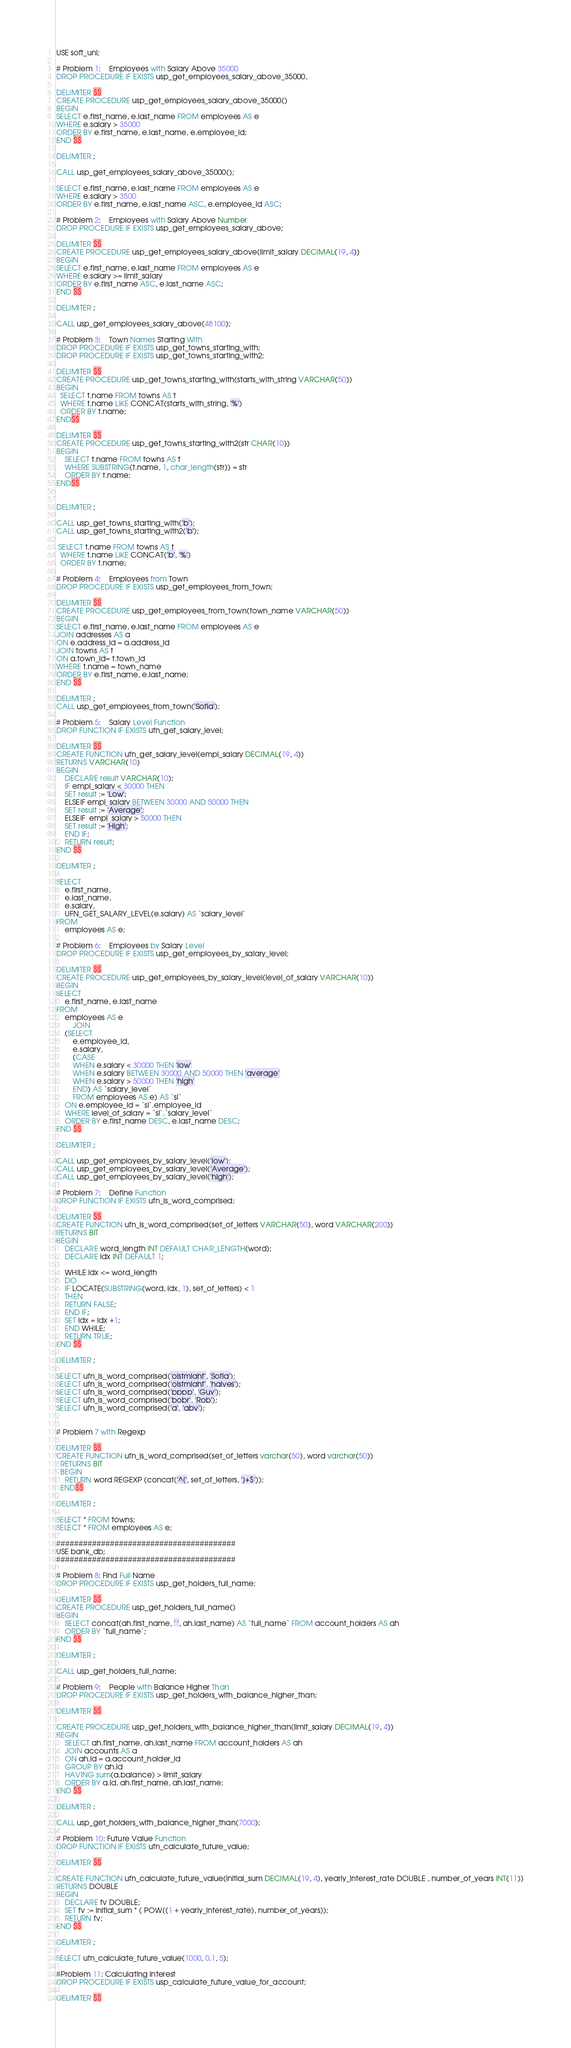Convert code to text. <code><loc_0><loc_0><loc_500><loc_500><_SQL_>USE soft_uni;

# Problem 1:	Employees with Salary Above 35000
DROP PROCEDURE IF EXISTS usp_get_employees_salary_above_35000,

DELIMITER $$
CREATE PROCEDURE usp_get_employees_salary_above_35000() 
BEGIN
SELECT e.first_name, e.last_name FROM employees AS e
WHERE e.salary > 35000
ORDER BY e.first_name, e.last_name, e.employee_id; 
END $$

DELIMITER ;

CALL usp_get_employees_salary_above_35000();

SELECT e.first_name, e.last_name FROM employees AS e
WHERE e.salary > 3500
ORDER BY e.first_name, e.last_name ASC, e.employee_id ASC; 

# Problem 2:	Employees with Salary Above Number
DROP PROCEDURE IF EXISTS usp_get_employees_salary_above;

DELIMITER $$
CREATE PROCEDURE usp_get_employees_salary_above(limit_salary DECIMAL(19, 4))
BEGIN
SELECT e.first_name, e.last_name FROM employees AS e
WHERE e.salary >= limit_salary
ORDER BY e.first_name ASC, e.last_name ASC;
END $$

DELIMITER ;

CALL usp_get_employees_salary_above(48100);

# Problem 3:	Town Names Starting With
DROP PROCEDURE IF EXISTS usp_get_towns_starting_with;
DROP PROCEDURE IF EXISTS usp_get_towns_starting_with2;

DELIMITER $$
CREATE PROCEDURE usp_get_towns_starting_with(starts_with_string VARCHAR(50))
BEGIN
  SELECT t.name FROM towns AS t
  WHERE t.name LIKE CONCAT(starts_with_string, '%')
  ORDER BY t.name;
END$$

DELIMITER $$
CREATE PROCEDURE usp_get_towns_starting_with2(str CHAR(10))
BEGIN
	SELECT t.name FROM towns AS t
	WHERE SUBSTRING(t.name, 1, char_length(str)) = str
    ORDER BY t.name;
END$$


DELIMITER ;

CALL usp_get_towns_starting_with('b');
CALL usp_get_towns_starting_with2('b');

 SELECT t.name FROM towns AS t
  WHERE t.name LIKE CONCAT('b', '%')
  ORDER BY t.name;

# Problem 4:	Employees from Town
DROP PROCEDURE IF EXISTS usp_get_employees_from_town;

DELIMITER $$
CREATE PROCEDURE usp_get_employees_from_town(town_name VARCHAR(50))
BEGIN
SELECT e.first_name, e.last_name FROM employees AS e
JOIN addresses AS a
ON e.address_id = a.address_id
JOIN towns AS t
ON a.town_id= t.town_id
WHERE t.name = town_name
ORDER BY e.first_name, e.last_name;
END $$

DELIMITER ;
CALL usp_get_employees_from_town('Sofia');

# Problem 5:	Salary Level Function
DROP FUNCTION IF EXISTS ufn_get_salary_level;

DELIMITER $$
CREATE FUNCTION ufn_get_salary_level(empl_salary DECIMAL(19, 4))
RETURNS VARCHAR(10) 
BEGIN
	DECLARE result VARCHAR(10);
    IF empl_salary < 30000 THEN
    SET result := 'Low';
    ELSEIF empl_salary BETWEEN 30000 AND 50000 THEN
    SET result := 'Average';
    ELSEIF  empl_salary > 50000 THEN
    SET result := 'High';
    END IF;
	RETURN result;
END $$

DELIMITER ;

SELECT 
    e.first_name,
    e.last_name,
    e.salary,
    UFN_GET_SALARY_LEVEL(e.salary) AS `salary_level`
FROM
    employees AS e;

# Problem 6:	Employees by Salary Level
DROP PROCEDURE IF EXISTS usp_get_employees_by_salary_level;

DELIMITER $$
CREATE PROCEDURE usp_get_employees_by_salary_level(level_of_salary VARCHAR(10))
BEGIN
SELECT 
    e.first_name, e.last_name
FROM
    employees AS e
        JOIN
    (SELECT 
        e.employee_id, 
        e.salary,
        (CASE 
        WHEN e.salary < 30000 THEN 'low'
        WHEN e.salary BETWEEN 30000 AND 50000 THEN 'average'
        WHEN e.salary > 50000 THEN 'high'
        END) AS `salary_level`
		FROM employees AS e) AS `sl`
	ON e.employee_id = `sl`.employee_id
    WHERE level_of_salary = `sl`.`salary_level`
    ORDER BY e.first_name DESC, e.last_name DESC;
END $$

DELIMITER ;

CALL usp_get_employees_by_salary_level('low');
CALL usp_get_employees_by_salary_level('Average');
CALL usp_get_employees_by_salary_level('high');

# Problem 7:	Define Function
DROP FUNCTION IF EXISTS ufn_is_word_comprised;

DELIMITER $$
CREATE FUNCTION ufn_is_word_comprised(set_of_letters VARCHAR(50), word VARCHAR(200))
RETURNS BIT
BEGIN 
	DECLARE word_length INT DEFAULT CHAR_LENGTH(word);
    DECLARE idx INT DEFAULT 1;
    
    WHILE idx <= word_length
    DO
    IF LOCATE(SUBSTRING(word, idx, 1), set_of_letters) < 1
    THEN
    RETURN FALSE;
    END IF;
    SET idx = idx +1;
    END WHILE;
    RETURN TRUE;
END $$

DELIMITER ;

SELECT ufn_is_word_comprised('oistmiahf', 'Sofia');
SELECT ufn_is_word_comprised('oistmiahf', 'halves');
SELECT ufn_is_word_comprised('pppp', 'Guy');
SELECT ufn_is_word_comprised('bobr', 'Rob');
SELECT ufn_is_word_comprised('a', 'abv');


# Problem 7 with Regexp

DELIMITER $$
CREATE FUNCTION ufn_is_word_comprised(set_of_letters varchar(50), word varchar(50))
  RETURNS BIT
  BEGIN
    RETURN word REGEXP (concat('^[', set_of_letters, ']+$'));
  END$$

DELIMITER ;

SELECT * FROM towns;
SELECT * FROM employees AS e;

########################################
USE bank_db;
########################################

# Problem 8: Find Full Name
DROP PROCEDURE IF EXISTS usp_get_holders_full_name;

DELIMITER $$
CREATE PROCEDURE usp_get_holders_full_name()
BEGIN
	SELECT concat(ah.first_name, ' ', ah.last_name) AS `full_name` FROM account_holders AS ah
    ORDER BY `full_name`;
END $$

DELIMITER ;

CALL usp_get_holders_full_name;

# Problem 9:	People with Balance Higher Than
DROP PROCEDURE IF EXISTS usp_get_holders_with_balance_higher_than;

DELIMITER $$

CREATE PROCEDURE usp_get_holders_with_balance_higher_than(limit_salary DECIMAL(19, 4))
BEGIN
	SELECT ah.first_name, ah.last_name FROM account_holders AS ah
	JOIN accounts AS a
	ON ah.id = a.account_holder_id
	GROUP BY ah.id
	HAVING sum(a.balance) > limit_salary
	ORDER BY a.id, ah.first_name, ah.last_name;
END $$

DELIMITER ;

CALL usp_get_holders_with_balance_higher_than(7000);

# Problem 10: Future Value Function
DROP FUNCTION IF EXISTS ufn_calculate_future_value;

DELIMITER $$

CREATE FUNCTION ufn_calculate_future_value(initial_sum DECIMAL(19, 4), yearly_interest_rate DOUBLE , number_of_years INT(11))
RETURNS DOUBLE
BEGIN
	DECLARE fv DOUBLE;
    SET fv := initial_sum * ( POW((1 + yearly_interest_rate), number_of_years));
	RETURN fv;
END $$

DELIMITER ;

SELECT ufn_calculate_future_value(1000, 0.1, 5);

#Problem 11: Calculating Interest
DROP PROCEDURE IF EXISTS usp_calculate_future_value_for_account;

DELIMITER $$
</code> 